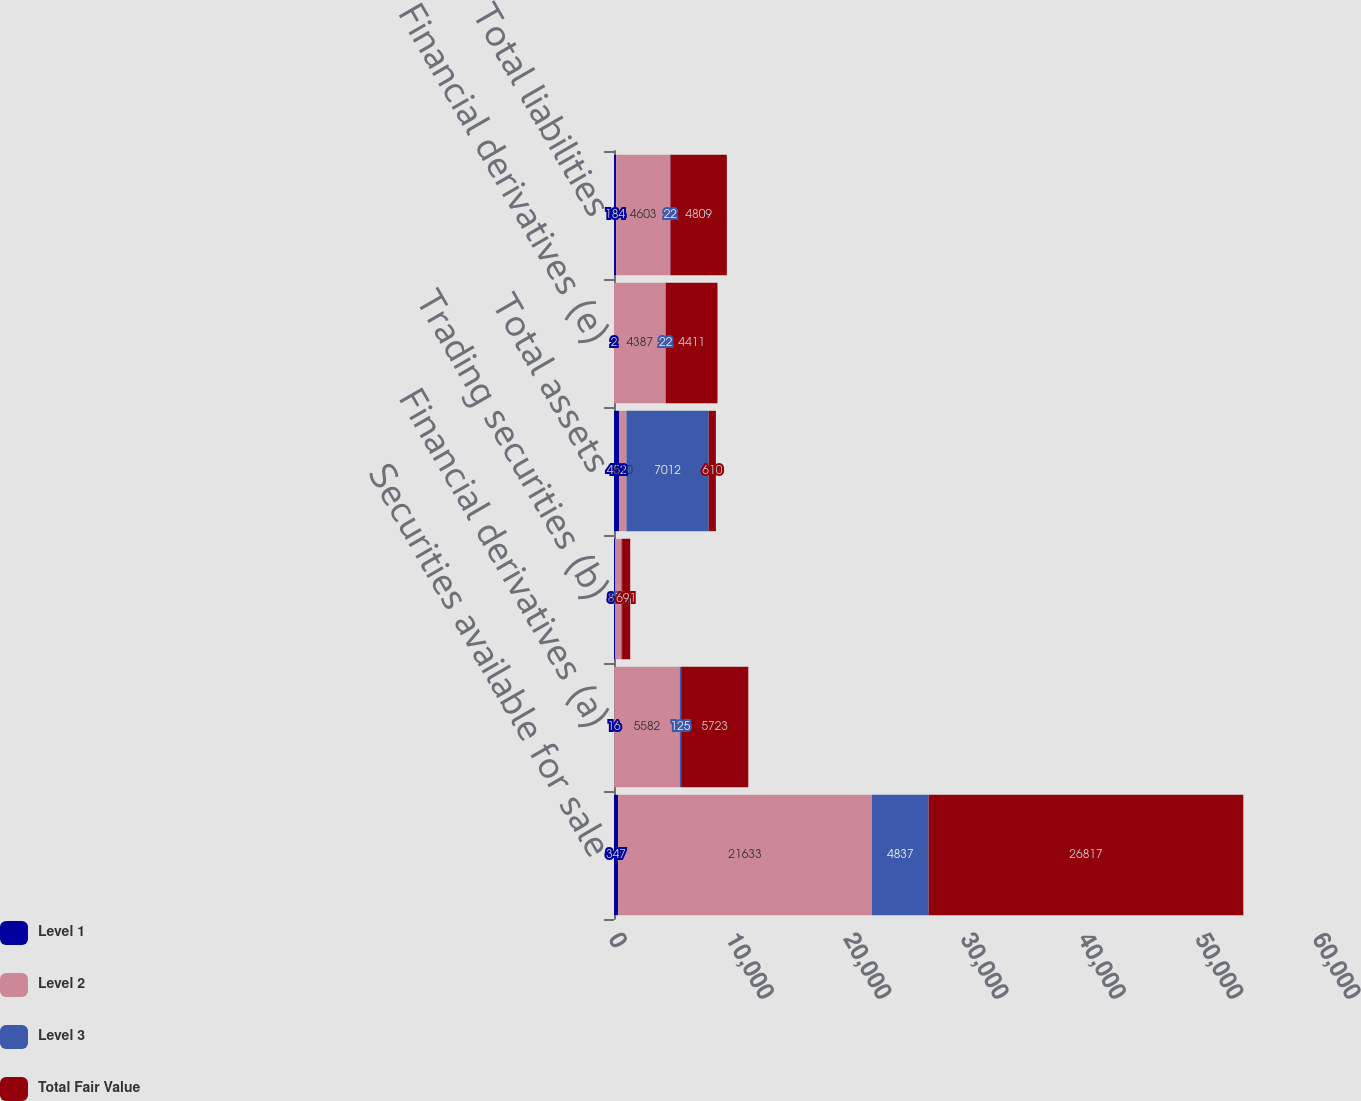Convert chart to OTSL. <chart><loc_0><loc_0><loc_500><loc_500><stacked_bar_chart><ecel><fcel>Securities available for sale<fcel>Financial derivatives (a)<fcel>Trading securities (b)<fcel>Total assets<fcel>Financial derivatives (e)<fcel>Total liabilities<nl><fcel>Level 1<fcel>347<fcel>16<fcel>89<fcel>452<fcel>2<fcel>184<nl><fcel>Level 2<fcel>21633<fcel>5582<fcel>529<fcel>610<fcel>4387<fcel>4603<nl><fcel>Level 3<fcel>4837<fcel>125<fcel>73<fcel>7012<fcel>22<fcel>22<nl><fcel>Total Fair Value<fcel>26817<fcel>5723<fcel>691<fcel>610<fcel>4411<fcel>4809<nl></chart> 